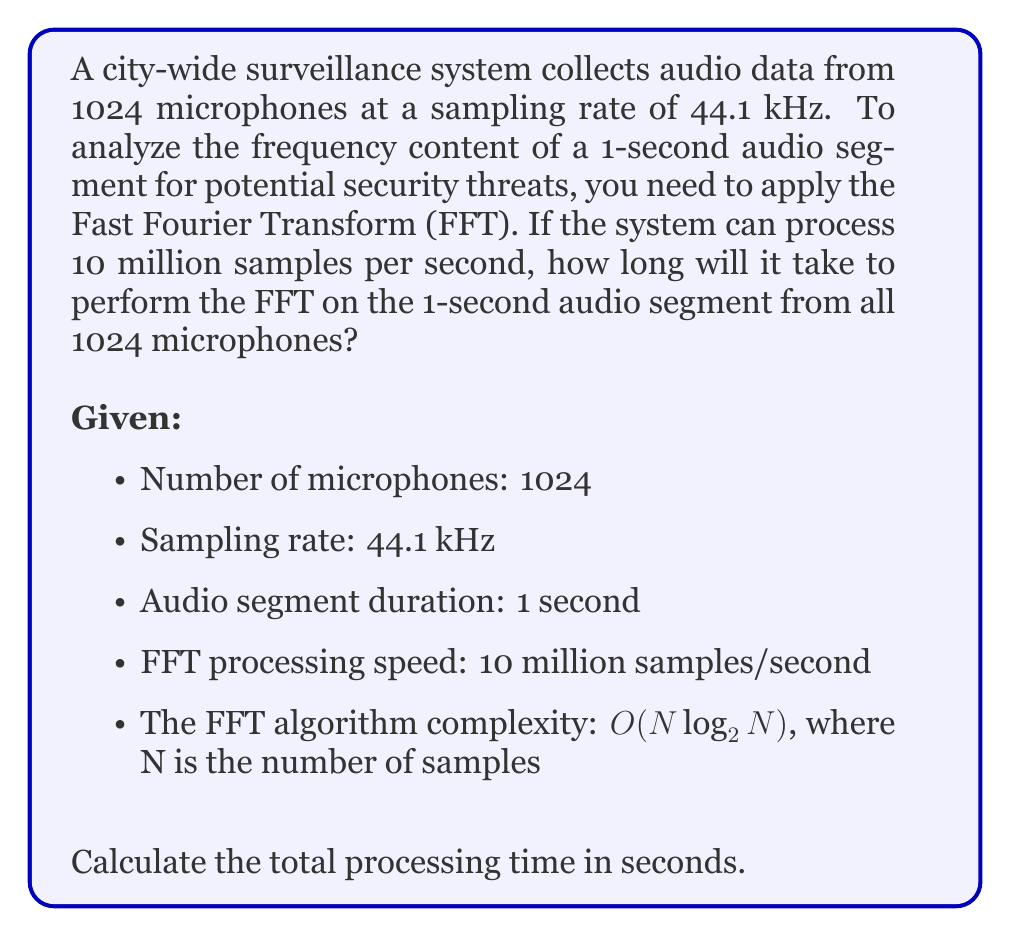Show me your answer to this math problem. Let's approach this problem step by step:

1. Calculate the number of samples per microphone:
   Samples per microphone = Sampling rate × Duration
   $N = 44100 \text{ Hz} \times 1 \text{ s} = 44100$ samples

2. The FFT algorithm has a complexity of $O(N \log_2 N)$. For practical purposes, we can approximate the number of operations as $5N \log_2 N$.

3. Calculate the number of operations for one microphone:
   Operations per microphone $= 5N \log_2 N$
   $= 5 \times 44100 \times \log_2(44100)$
   $= 5 \times 44100 \times 15.43$
   $= 3,401,115$ operations

4. Calculate the total number of operations for all microphones:
   Total operations $= 3,401,115 \times 1024 = 3,482,741,760$

5. Calculate the processing time:
   Processing time $= \frac{\text{Total operations}}{\text{Processing speed}}$
   $= \frac{3,482,741,760}{10,000,000 \text{ samples/s}}$
   $= 348.27 \text{ seconds}$

Therefore, it will take approximately 348.27 seconds (or about 5.8 minutes) to process the FFT for all 1024 microphones.
Answer: 348.27 seconds 